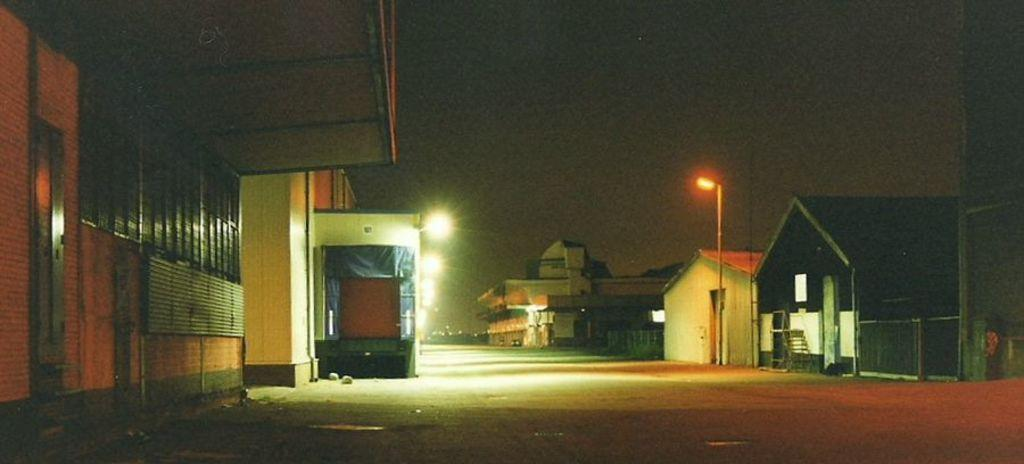What time of day is depicted in the image? The image depicts a night view. What type of structures can be seen in the image? There are houses visible in the image. What other object can be seen in the image besides the houses? There is a pole in the image. Where is the cub playing with the lumber in the image? There is no cub or lumber present in the image. Can you tell me how many frogs are visible in the image? There are no frogs visible in the image. 